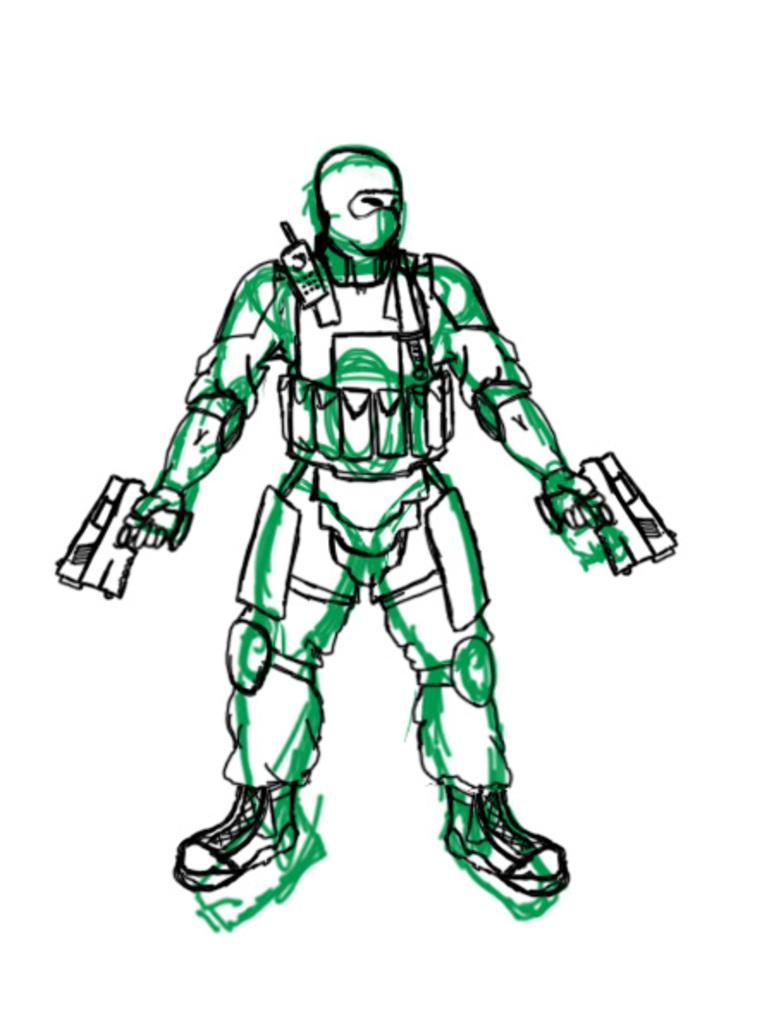What is the main subject of the image? There is a drawing in the image. What colors are used in the drawing? The drawing has green, black, and white colors. What is the color of the background in the image? The background of the image is white. How many pigs can be seen in the drawing? There are no pigs present in the image, as it features a drawing with green, black, and white colors on a white background. What type of drain is visible in the drawing? There is no drain present in the image, as it features a drawing with green, black, and white colors on a white background. 